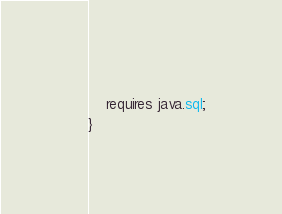<code> <loc_0><loc_0><loc_500><loc_500><_Java_>	
	requires java.sql;
}</code> 